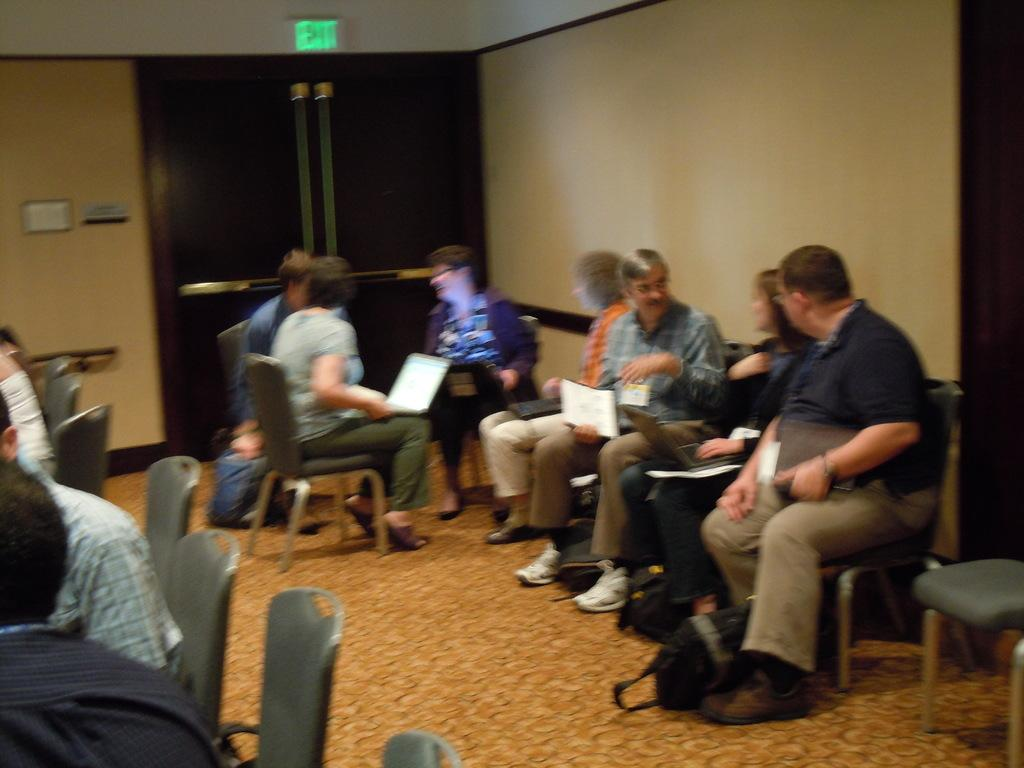What are the people in the image doing? The people in the image are sitting on chairs. What objects are the people holding in the image? The people are holding laptops. What can be seen in the background of the image? There is a wall visible in the background of the image. How many rabbits are sitting on the chairs with the people in the image? There are no rabbits present in the image; only people holding laptops are visible. 